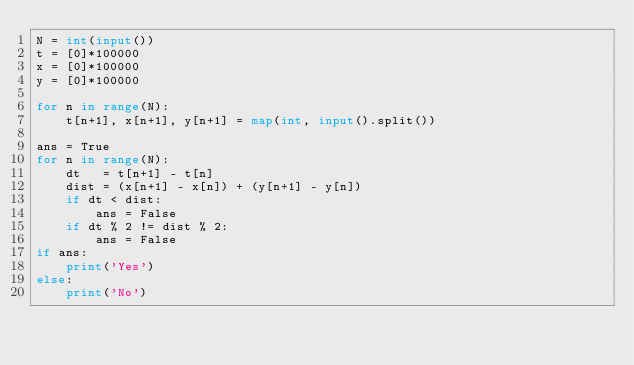<code> <loc_0><loc_0><loc_500><loc_500><_Python_>N = int(input())
t = [0]*100000
x = [0]*100000
y = [0]*100000

for n in range(N):
    t[n+1], x[n+1], y[n+1] = map(int, input().split())

ans = True
for n in range(N):
    dt   = t[n+1] - t[n]
    dist = (x[n+1] - x[n]) + (y[n+1] - y[n])
    if dt < dist:
        ans = False
    if dt % 2 != dist % 2:
        ans = False
if ans:
    print('Yes')
else:
    print('No')</code> 